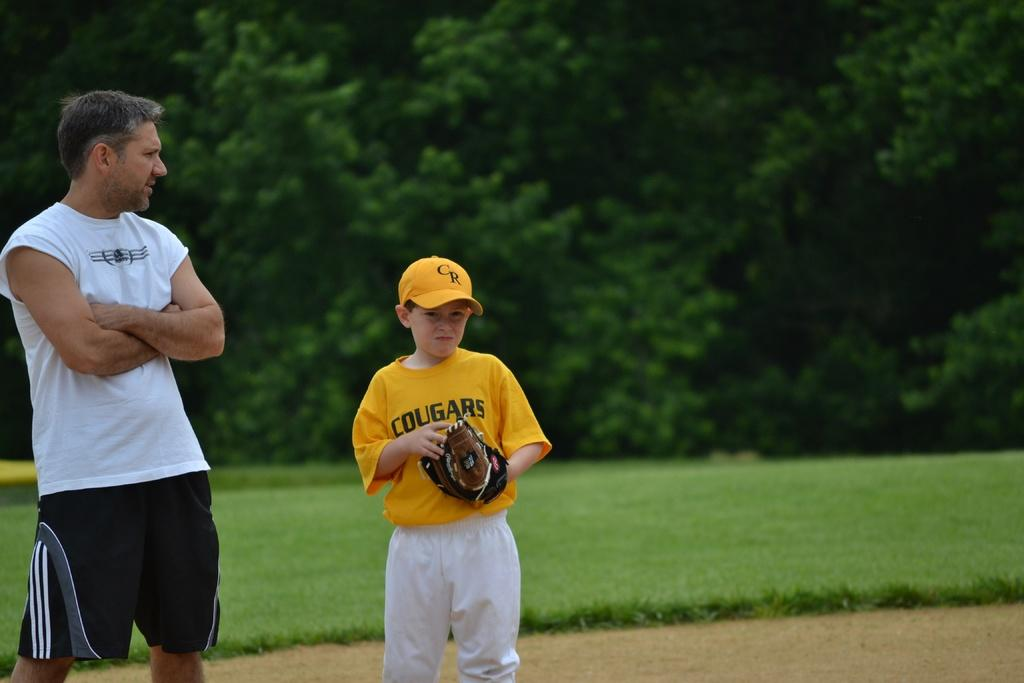Provide a one-sentence caption for the provided image. A young boy in a cougars jersey is wearing a baseball glove. 